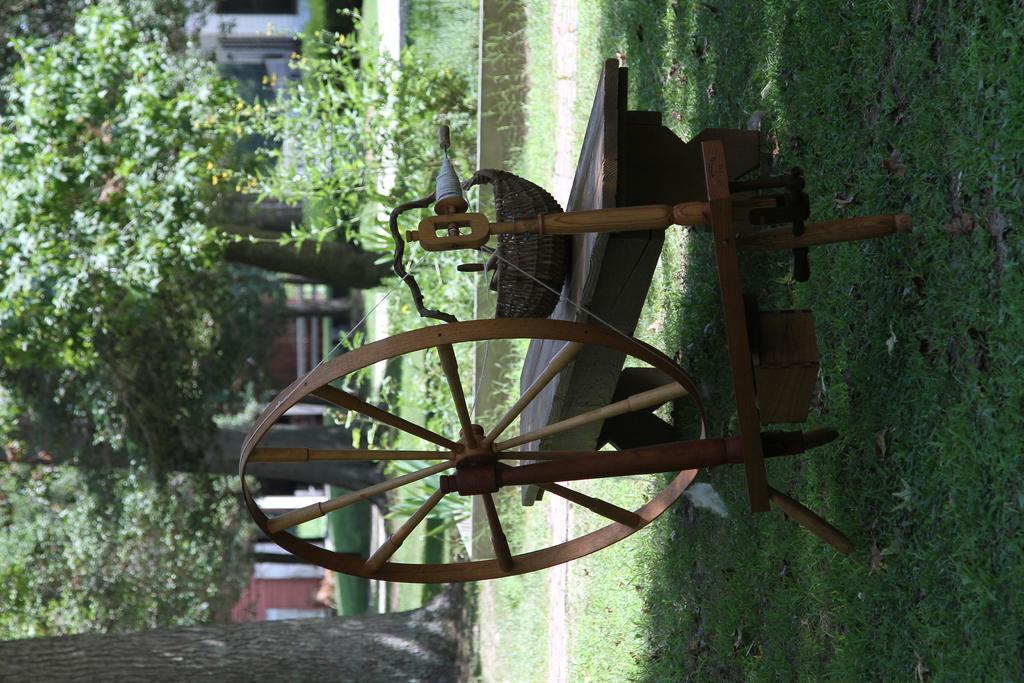In one or two sentences, can you explain what this image depicts? In this image there is a bench having a basket on it. Beside there is a wheel having a thread over it which is tied to a pole which is on the grass land. There are few plants. Behind there are few trees. Background there are few buildings. 